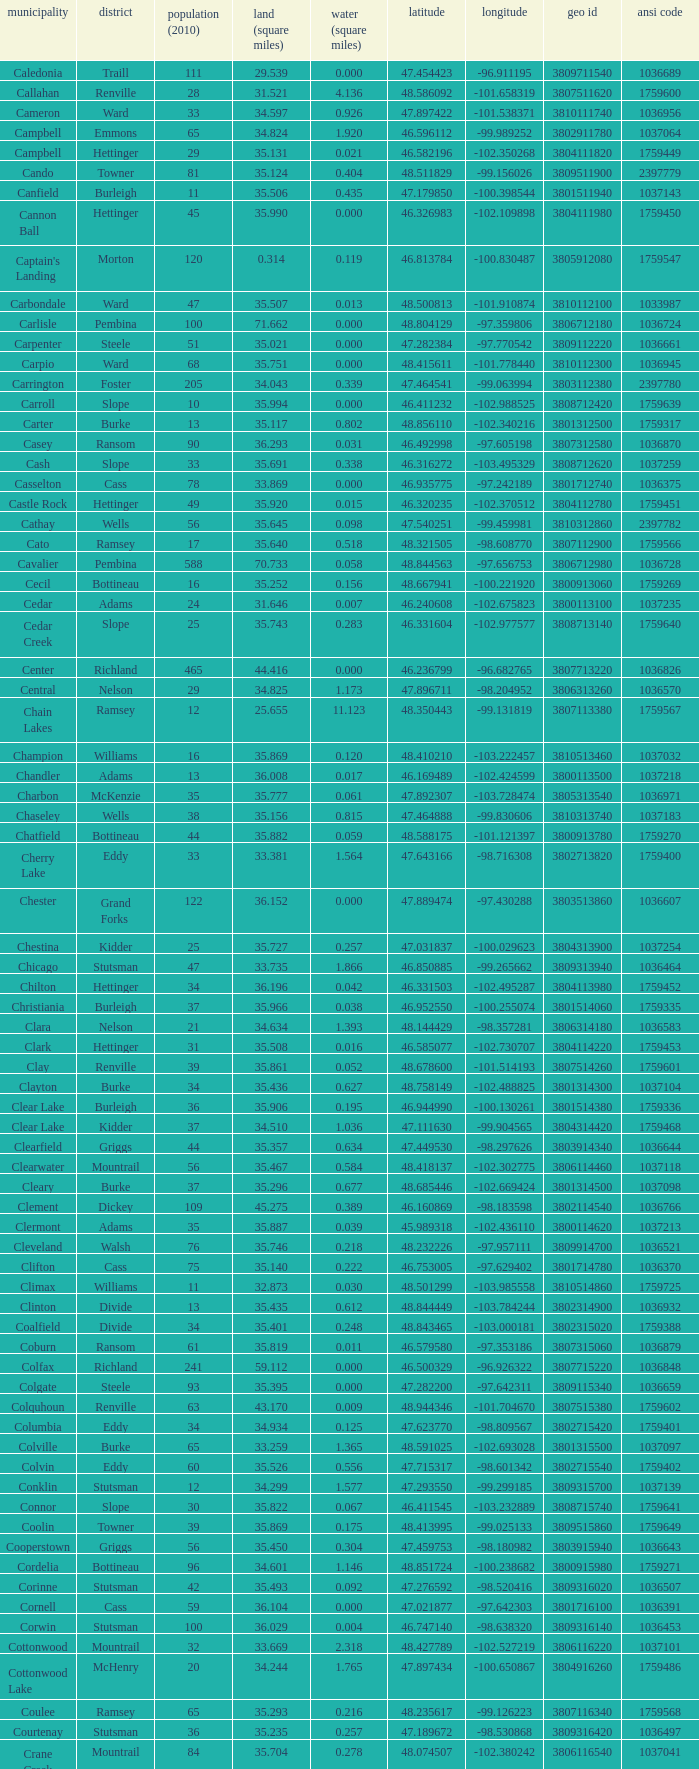What was the township with a geo ID of 3807116660? Creel. 